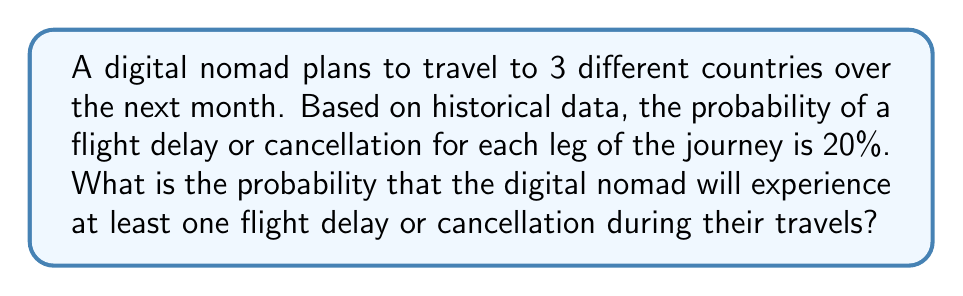Give your solution to this math problem. Let's approach this step-by-step:

1) First, let's consider the probability of all flights being on time. For each flight, the probability of being on time is 80% (1 - 0.20 = 0.80).

2) Since there are 3 independent flights, we can use the multiplication rule of probability. The probability of all flights being on time is:

   $$P(\text{all on time}) = 0.80 \times 0.80 \times 0.80 = 0.80^3 = 0.512$$

3) Now, the probability of experiencing at least one delay or cancellation is the complement of all flights being on time:

   $$P(\text{at least one delay}) = 1 - P(\text{all on time})$$

4) Substituting the value we calculated:

   $$P(\text{at least one delay}) = 1 - 0.512 = 0.488$$

5) Therefore, the probability of experiencing at least one flight delay or cancellation is 0.488 or 48.8%.
Answer: 0.488 